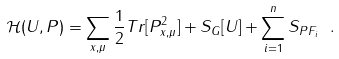Convert formula to latex. <formula><loc_0><loc_0><loc_500><loc_500>\mathcal { H } ( U , P ) = \sum _ { x , \mu } \frac { 1 } { 2 } T r [ P _ { x , \mu } ^ { 2 } ] + S _ { G } [ U ] + \sum _ { i = 1 } ^ { n } S _ { P F _ { i } } \ .</formula> 